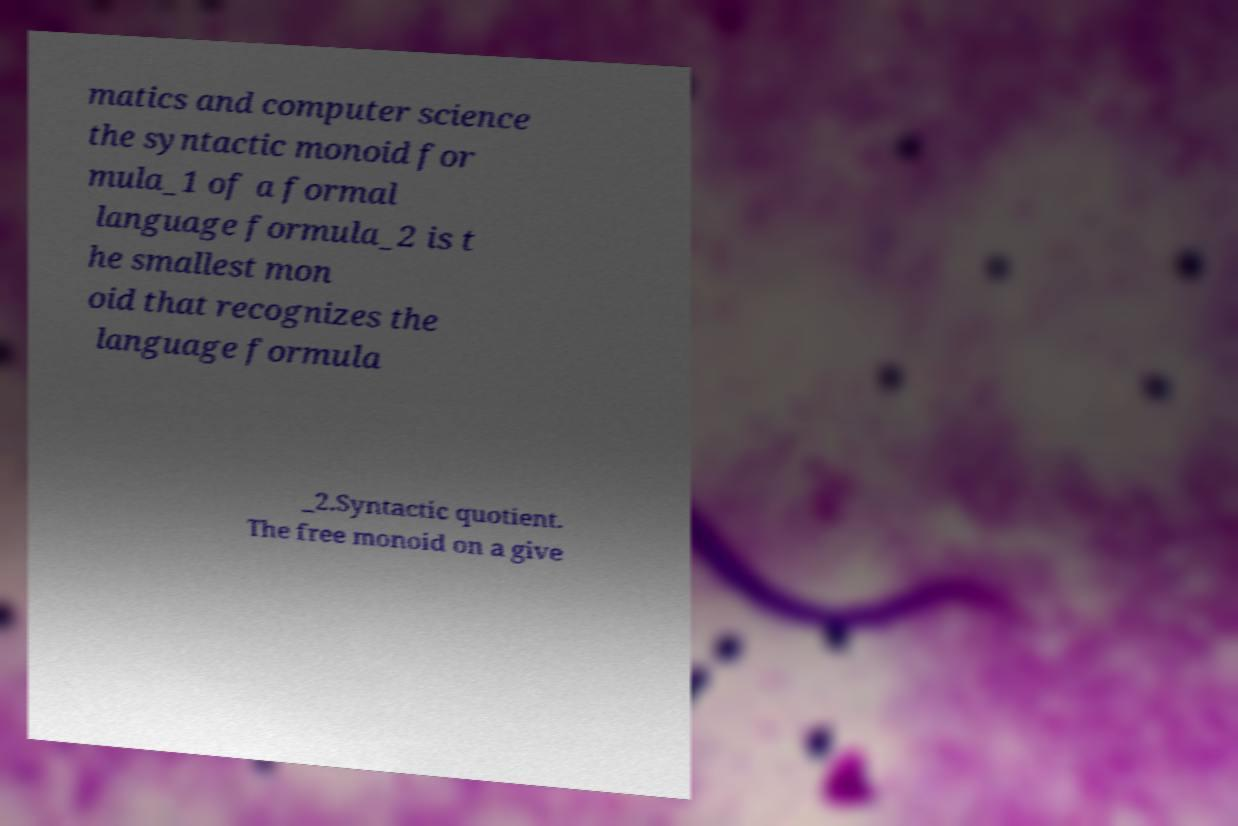I need the written content from this picture converted into text. Can you do that? matics and computer science the syntactic monoid for mula_1 of a formal language formula_2 is t he smallest mon oid that recognizes the language formula _2.Syntactic quotient. The free monoid on a give 